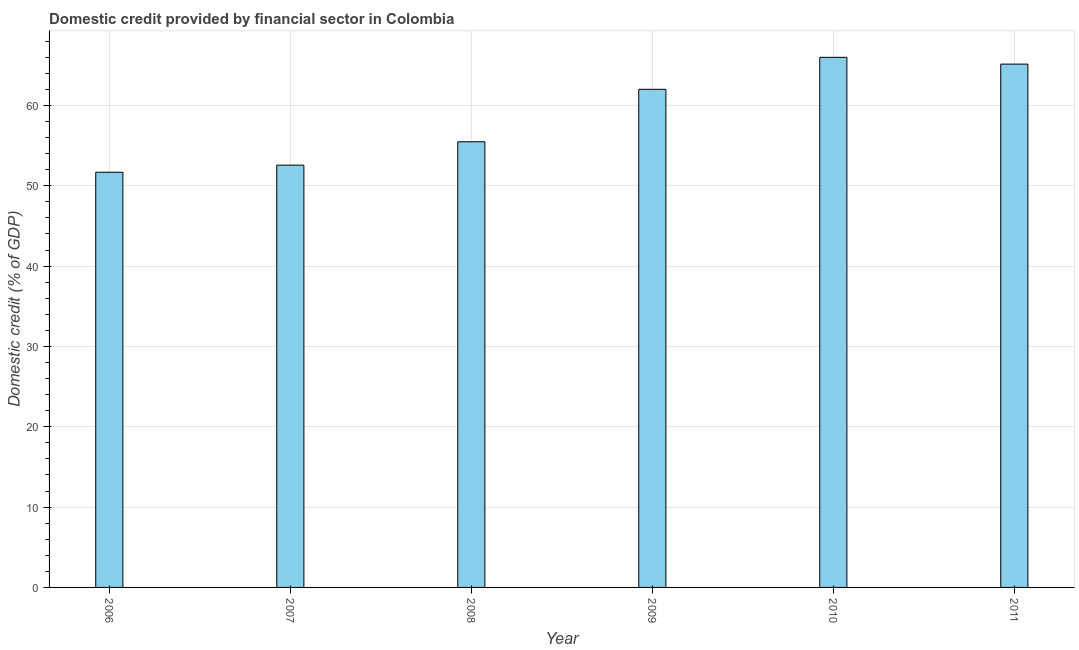What is the title of the graph?
Give a very brief answer. Domestic credit provided by financial sector in Colombia. What is the label or title of the Y-axis?
Offer a terse response. Domestic credit (% of GDP). What is the domestic credit provided by financial sector in 2010?
Offer a terse response. 65.99. Across all years, what is the maximum domestic credit provided by financial sector?
Your response must be concise. 65.99. Across all years, what is the minimum domestic credit provided by financial sector?
Offer a terse response. 51.68. In which year was the domestic credit provided by financial sector maximum?
Your response must be concise. 2010. In which year was the domestic credit provided by financial sector minimum?
Your response must be concise. 2006. What is the sum of the domestic credit provided by financial sector?
Make the answer very short. 352.87. What is the difference between the domestic credit provided by financial sector in 2006 and 2011?
Provide a succinct answer. -13.46. What is the average domestic credit provided by financial sector per year?
Offer a terse response. 58.81. What is the median domestic credit provided by financial sector?
Your response must be concise. 58.74. Do a majority of the years between 2008 and 2010 (inclusive) have domestic credit provided by financial sector greater than 26 %?
Make the answer very short. Yes. Is the domestic credit provided by financial sector in 2009 less than that in 2011?
Offer a very short reply. Yes. Is the difference between the domestic credit provided by financial sector in 2010 and 2011 greater than the difference between any two years?
Offer a terse response. No. What is the difference between the highest and the second highest domestic credit provided by financial sector?
Your response must be concise. 0.84. What is the difference between the highest and the lowest domestic credit provided by financial sector?
Offer a very short reply. 14.31. In how many years, is the domestic credit provided by financial sector greater than the average domestic credit provided by financial sector taken over all years?
Ensure brevity in your answer.  3. Are the values on the major ticks of Y-axis written in scientific E-notation?
Give a very brief answer. No. What is the Domestic credit (% of GDP) in 2006?
Your answer should be compact. 51.68. What is the Domestic credit (% of GDP) of 2007?
Ensure brevity in your answer.  52.57. What is the Domestic credit (% of GDP) in 2008?
Offer a very short reply. 55.48. What is the Domestic credit (% of GDP) of 2009?
Your response must be concise. 62.01. What is the Domestic credit (% of GDP) in 2010?
Your answer should be compact. 65.99. What is the Domestic credit (% of GDP) of 2011?
Offer a terse response. 65.14. What is the difference between the Domestic credit (% of GDP) in 2006 and 2007?
Your response must be concise. -0.89. What is the difference between the Domestic credit (% of GDP) in 2006 and 2008?
Provide a succinct answer. -3.79. What is the difference between the Domestic credit (% of GDP) in 2006 and 2009?
Your response must be concise. -10.32. What is the difference between the Domestic credit (% of GDP) in 2006 and 2010?
Offer a terse response. -14.31. What is the difference between the Domestic credit (% of GDP) in 2006 and 2011?
Provide a short and direct response. -13.46. What is the difference between the Domestic credit (% of GDP) in 2007 and 2008?
Keep it short and to the point. -2.91. What is the difference between the Domestic credit (% of GDP) in 2007 and 2009?
Make the answer very short. -9.44. What is the difference between the Domestic credit (% of GDP) in 2007 and 2010?
Provide a succinct answer. -13.42. What is the difference between the Domestic credit (% of GDP) in 2007 and 2011?
Make the answer very short. -12.57. What is the difference between the Domestic credit (% of GDP) in 2008 and 2009?
Your answer should be very brief. -6.53. What is the difference between the Domestic credit (% of GDP) in 2008 and 2010?
Your answer should be very brief. -10.51. What is the difference between the Domestic credit (% of GDP) in 2008 and 2011?
Provide a succinct answer. -9.67. What is the difference between the Domestic credit (% of GDP) in 2009 and 2010?
Your response must be concise. -3.98. What is the difference between the Domestic credit (% of GDP) in 2009 and 2011?
Give a very brief answer. -3.14. What is the difference between the Domestic credit (% of GDP) in 2010 and 2011?
Provide a succinct answer. 0.84. What is the ratio of the Domestic credit (% of GDP) in 2006 to that in 2008?
Your answer should be very brief. 0.93. What is the ratio of the Domestic credit (% of GDP) in 2006 to that in 2009?
Your answer should be very brief. 0.83. What is the ratio of the Domestic credit (% of GDP) in 2006 to that in 2010?
Provide a succinct answer. 0.78. What is the ratio of the Domestic credit (% of GDP) in 2006 to that in 2011?
Provide a short and direct response. 0.79. What is the ratio of the Domestic credit (% of GDP) in 2007 to that in 2008?
Keep it short and to the point. 0.95. What is the ratio of the Domestic credit (% of GDP) in 2007 to that in 2009?
Offer a terse response. 0.85. What is the ratio of the Domestic credit (% of GDP) in 2007 to that in 2010?
Keep it short and to the point. 0.8. What is the ratio of the Domestic credit (% of GDP) in 2007 to that in 2011?
Make the answer very short. 0.81. What is the ratio of the Domestic credit (% of GDP) in 2008 to that in 2009?
Your answer should be very brief. 0.9. What is the ratio of the Domestic credit (% of GDP) in 2008 to that in 2010?
Offer a very short reply. 0.84. What is the ratio of the Domestic credit (% of GDP) in 2008 to that in 2011?
Ensure brevity in your answer.  0.85. What is the ratio of the Domestic credit (% of GDP) in 2009 to that in 2011?
Give a very brief answer. 0.95. What is the ratio of the Domestic credit (% of GDP) in 2010 to that in 2011?
Your response must be concise. 1.01. 